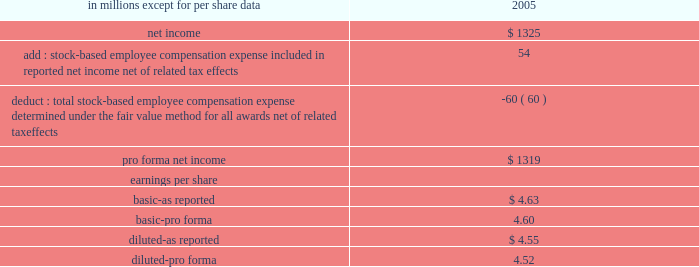Stock-based compensation we did not recognize stock-based employee compensation expense related to stock options granted before 2003 as permitted under accounting principles board opinion no .
25 , 201caccounting for stock issued to employees , 201d ( 201capb 25 201d ) .
Effective january 1 , 2003 , we adopted the fair value recognition provisions of sfas 123 , 201caccounting for stock- based compensation , 201d as amended by sfas 148 , 201caccounting for stock-based compensation-transition and disclosure , 201d prospectively to all employee awards granted , modified or settled after january 1 , 2003 .
We did not restate results for prior years upon our adoption of sfas 123 .
Since we adopted sfas 123 prospectively , the cost related to stock- based employee compensation included in net income for 2005 was less than what we would have recognized if we had applied the fair value based method to all awards since the original effective date of the standard .
In december 2004 , the fasb issued sfas 123r 201cshare- based payment , 201d which replaced sfas 123 and superseded apb 25 .
Sfas 123r requires compensation cost related to share-based payments to employees to be recognized in the financial statements based on their fair value .
We adopted sfas 123r effective january 1 , 2006 , using the modified prospective method of transition , which required the provisions of sfas 123r be applied to new awards and awards modified , repurchased or cancelled after the effective date .
It also required changes in the timing of expense recognition for awards granted to retirement-eligible employees and clarified the accounting for the tax effects of stock awards .
The adoption of sfas 123r did not have a significant impact on our consolidated financial statements .
The table shows the effect on 2005 net income and earnings per share if we had applied the fair value recognition provisions of sfas 123 , as amended , to all outstanding and unvested awards .
Pro forma net income and earnings per share ( a ) .
( a ) there were no differences between the gaap basis and pro forma basis of reporting 2006 net income and related per share amounts .
See note 18 stock-based compensation plans for additional information .
Recent accounting pronouncements in december 2007 , the fasb issued sfas 141 ( r ) , 201cbusiness combinations . 201d this statement will require all businesses acquired to be measured at the fair value of the consideration paid as opposed to the cost-based provisions of sfas 141 .
It will require an entity to recognize the assets acquired , the liabilities assumed , and any noncontrolling interest in the acquiree at the acquisition date , measured at their fair values as of that date .
Sfas 141 ( r ) requires the value of consideration paid including any future contingent consideration to be measured at fair value at the closing date of the transaction .
Also , restructuring costs and acquisition costs are to be expensed rather than included in the cost of the acquisition .
This guidance is effective for all acquisitions with closing dates after january 1 , 2009 .
In december 2007 , the fasb issued sfas 160 , 201caccounting and reporting of noncontrolling interests in consolidated financial statements , an amendment of arb no .
51 . 201d this statement amends arb no .
51 to establish accounting and reporting standards for the noncontrolling interest in a subsidiary and for the deconsolidation of a subsidiary .
It clarifies that a noncontrolling interest should be reported as equity in the consolidated financial statements .
This statement requires expanded disclosures that identify and distinguish between the interests of the parent 2019s owners and the interests of the noncontrolling owners of an entity .
This guidance is effective january 1 , 2009 .
We are currently analyzing the standard but do not expect the adoption to have a material impact on our consolidated financial statements .
In november 2007 , the sec issued staff accounting bulletin ( 201csab 201d ) no .
109 , that provides guidance regarding measuring the fair value of recorded written loan commitments .
The guidance indicates that the expected future cash flows related to servicing should be included in the fair value measurement of all written loan commitments that are accounted for at fair value through earnings .
Sab 109 is effective january 1 , 2008 , prospectively to loan commitments issued or modified after that date .
The adoption of this guidance is not expected to have a material effect on our results of operations or financial position .
In june 2007 , the aicpa issued statement of position 07-1 , 201cclarification of the scope of the audit and accounting guide 201cinvestment companies 201d and accounting by parent companies and equity method investors for investments in investment companies 201d ( 201csop 07-1 201d ) .
This statement provides guidance for determining whether an entity is within the scope of the aicpa audit and accounting guide investment companies ( 201cguide 201d ) and whether the specialized industry accounting principles of the guide should be retained in the financial statements of a parent company of an investment company or an equity method investor in an .
Was diluted-as reported net income per share greater than diluted-pro forma net income per share? 
Computations: (4.55 > 4.52)
Answer: yes. 